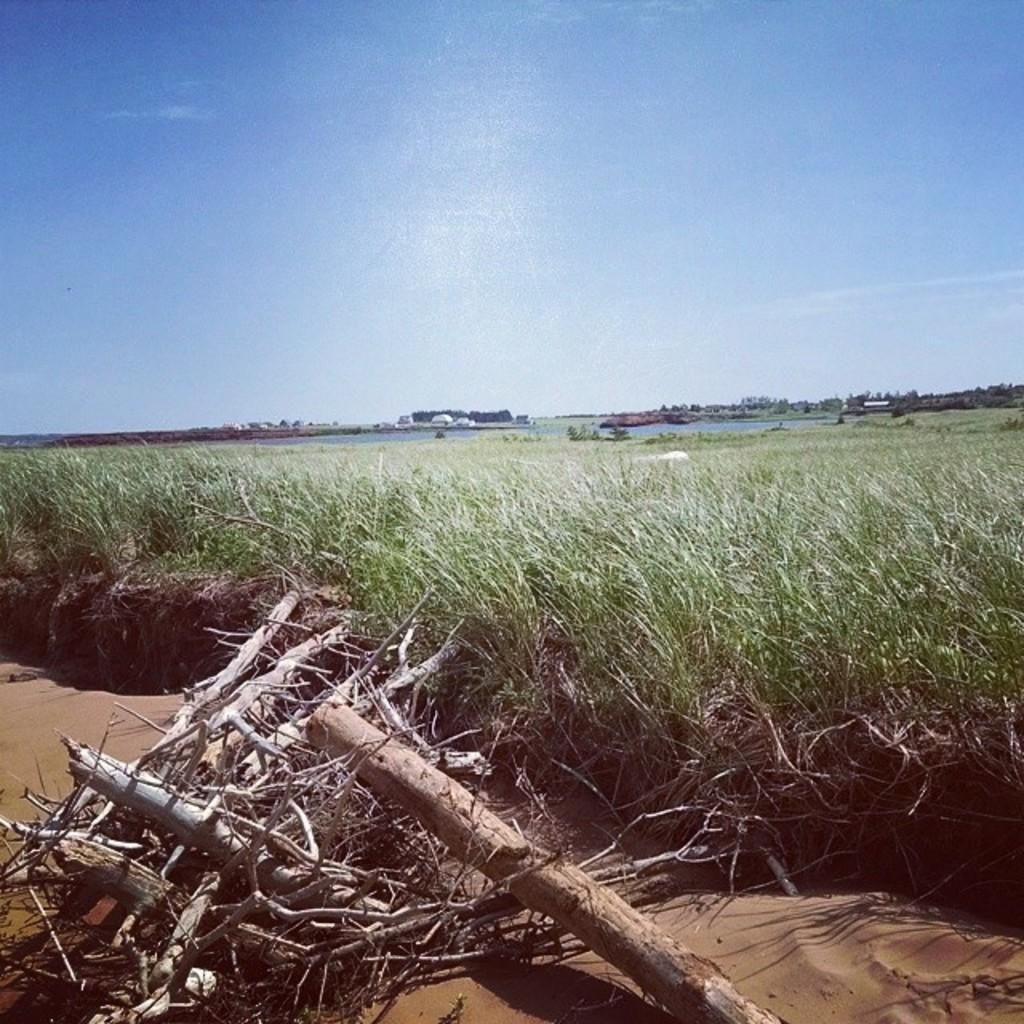Please provide a concise description of this image. In this image we can see sky, water, grass, sand, log and wooden sticks. 